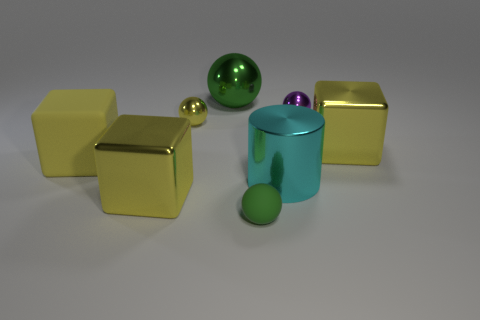There is a yellow metallic block left of the purple shiny object; is it the same size as the small yellow metallic ball? no 